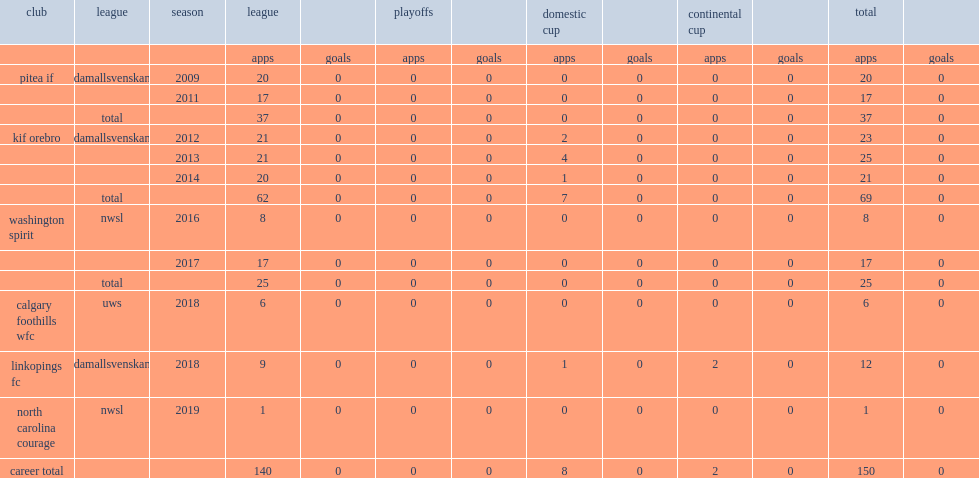How many matches did stephanie labbe play in the washington spirit, for the 2016 season of the national women's soccer league (nwsl)? 8.0. 